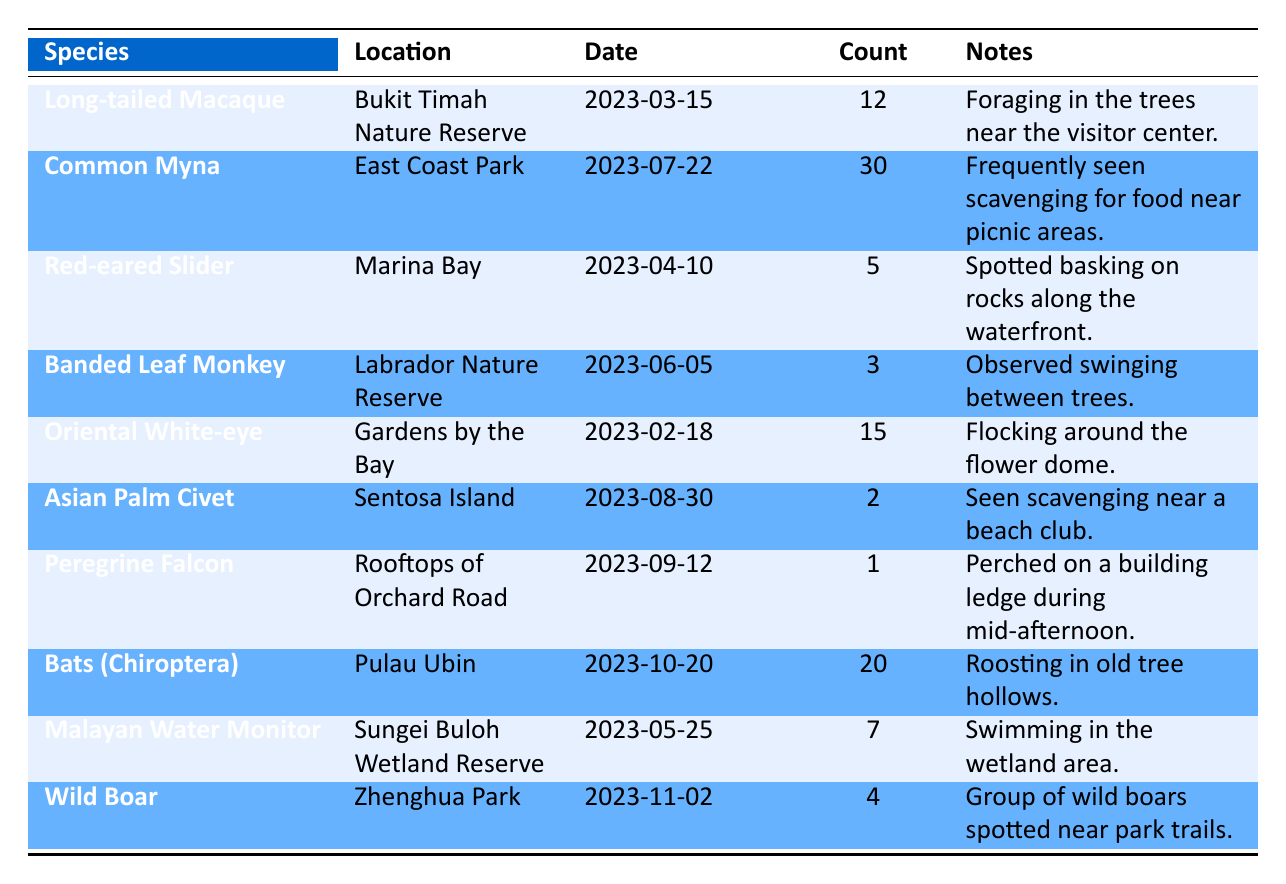What species had the highest sighting count in the table? Looking at the "Count" column in the table, the "Common Myna" has a sighting count of 30, which is higher than any other species.
Answer: Common Myna How many different species were reported in the urban sightings? By reviewing the table, we can see that there are 10 unique species listed in the "Species" column.
Answer: 10 Was the Long-tailed Macaque sighted in an urban area? The table shows "Bukit Timah Nature Reserve" as the location for the Long-tailed Macaque, which is not classified as an urban area.
Answer: No On which date was the Peregrine Falcon spotted? The "Date" column for the "Peregrine Falcon" shows it was sighted on "2023-09-12".
Answer: 2023-09-12 What is the total sighting count of all species reported in the table? Adding all the counts (12 + 30 + 5 + 3 + 15 + 2 + 1 + 20 + 7 + 4) gives us a total of 99 sightings.
Answer: 99 Which location had the least number of sightings reported? The "Count" for "Peregrine Falcon" (1) is the lowest, indicating Rooftops of Orchard Road had the fewest reported sightings.
Answer: Rooftops of Orchard Road Did any of the sightings occur in August? The table lists "Asian Palm Civet" sighted on "2023-08-30", confirming that there was at least one sighting in August.
Answer: Yes What is the average sighting count across all species? The total sightings (99) divided by the number of species (10) results in an average of 9.9 sightings per species.
Answer: 9.9 Which two species were observed on the same day and what were their counts? There are no species listed that were observed on the same date in the provided data. Each sighting date is unique.
Answer: None 